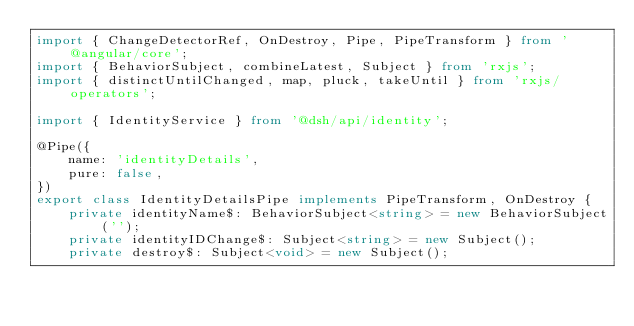<code> <loc_0><loc_0><loc_500><loc_500><_TypeScript_>import { ChangeDetectorRef, OnDestroy, Pipe, PipeTransform } from '@angular/core';
import { BehaviorSubject, combineLatest, Subject } from 'rxjs';
import { distinctUntilChanged, map, pluck, takeUntil } from 'rxjs/operators';

import { IdentityService } from '@dsh/api/identity';

@Pipe({
    name: 'identityDetails',
    pure: false,
})
export class IdentityDetailsPipe implements PipeTransform, OnDestroy {
    private identityName$: BehaviorSubject<string> = new BehaviorSubject('');
    private identityIDChange$: Subject<string> = new Subject();
    private destroy$: Subject<void> = new Subject();
</code> 